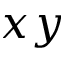Convert formula to latex. <formula><loc_0><loc_0><loc_500><loc_500>x y</formula> 